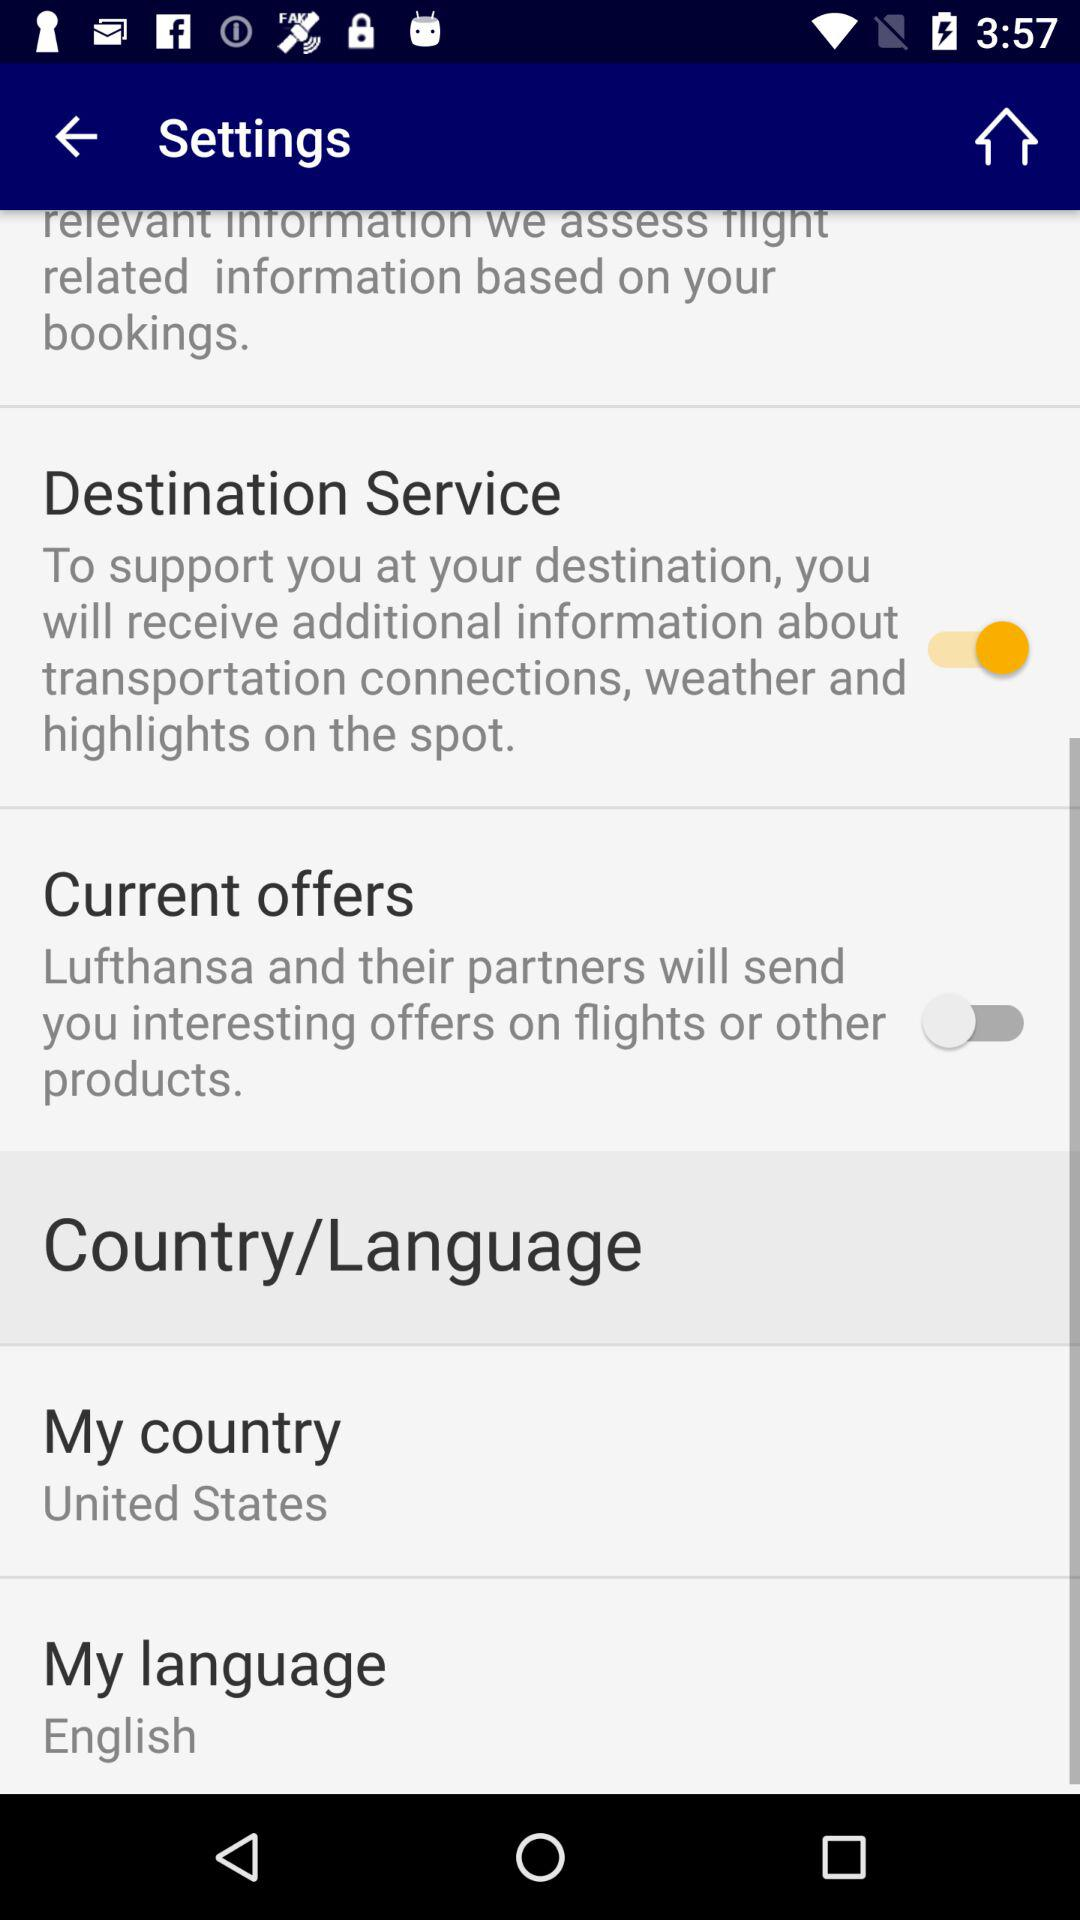What is the status of "Current offers"? The status is off. 